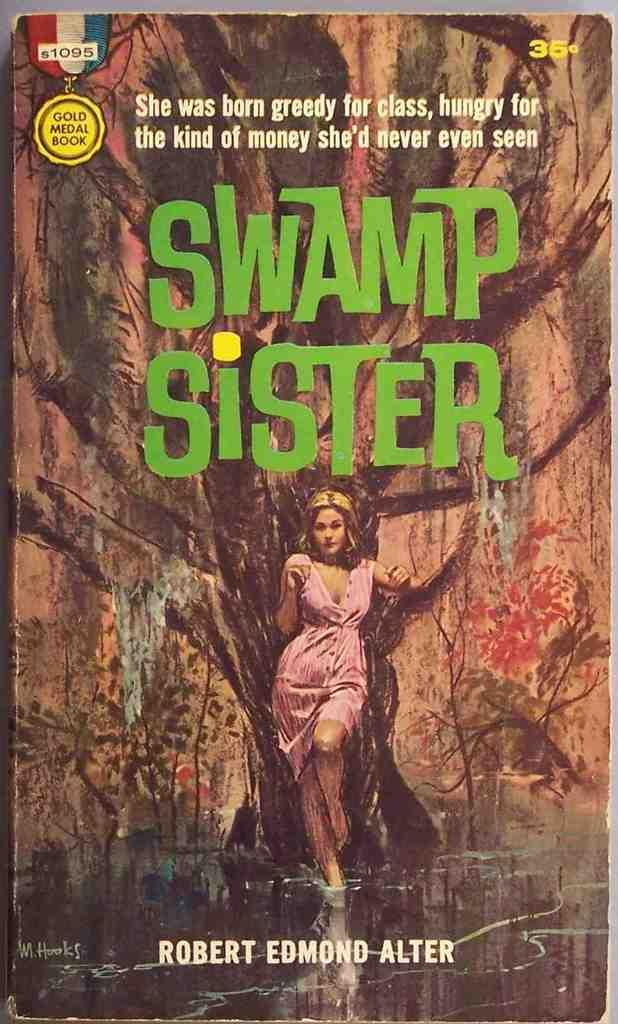Provide a one-sentence caption for the provided image. The Swamp Sister book was written about a greedy woman wanting money. 